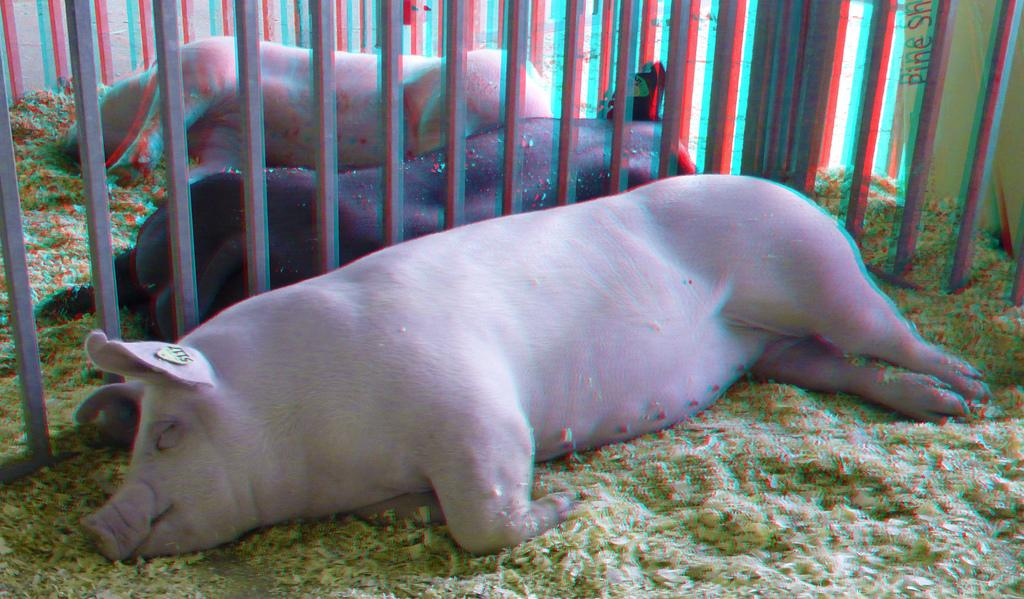How many pigs are in the image? There are three pigs in the image. Where are the pigs located in the image? The pigs are in a cage. What position are the pigs in within the cage? The pigs are laying on the ground. What type of basket is being used by the fireman in the image? There is no fireman or basket present in the image; it features three pigs in a cage. 